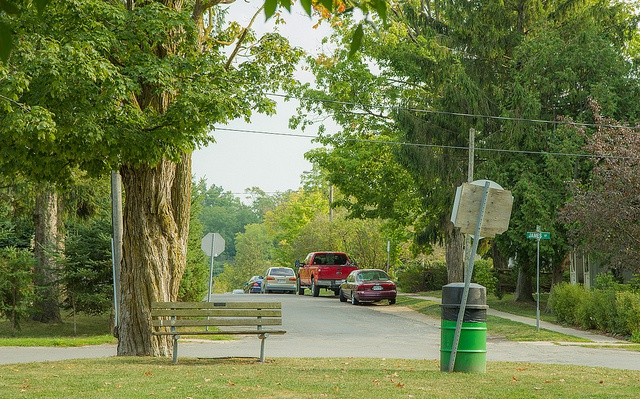Describe the objects in this image and their specific colors. I can see bench in darkgreen, olive, and darkgray tones, truck in darkgreen, black, brown, gray, and maroon tones, car in darkgreen, black, gray, maroon, and darkgray tones, car in darkgreen, darkgray, gray, and black tones, and stop sign in darkgreen, darkgray, gray, green, and lightgray tones in this image. 